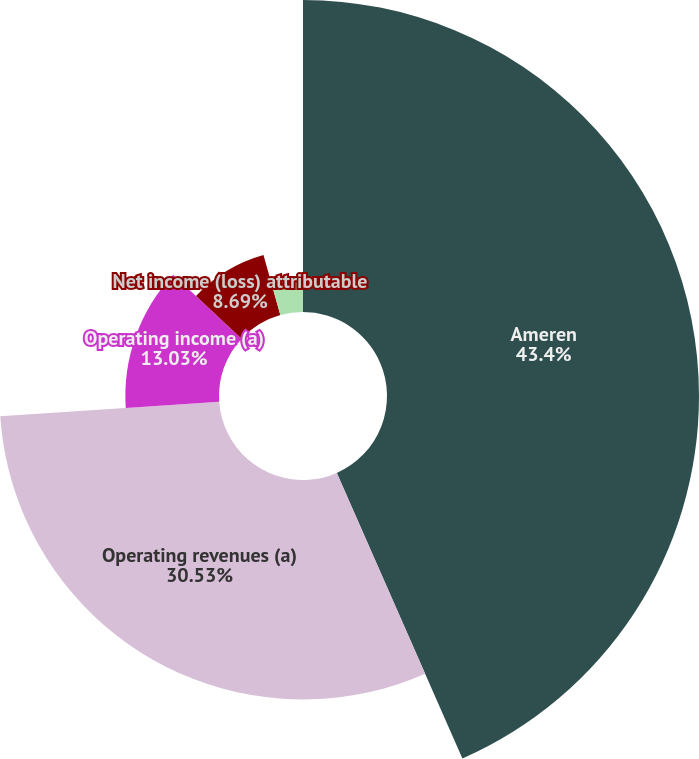Convert chart to OTSL. <chart><loc_0><loc_0><loc_500><loc_500><pie_chart><fcel>Ameren<fcel>Operating revenues (a)<fcel>Operating income (a)<fcel>Net income (loss) attributable<fcel>Earnings (loss) per common<nl><fcel>43.41%<fcel>30.53%<fcel>13.03%<fcel>8.69%<fcel>4.35%<nl></chart> 